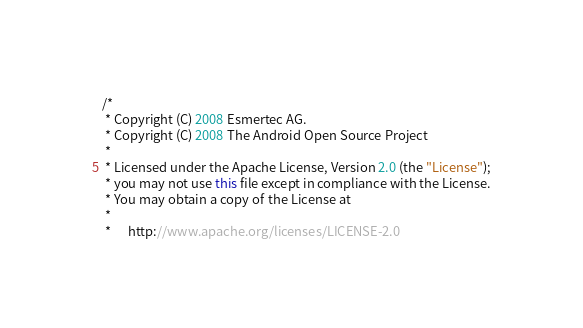Convert code to text. <code><loc_0><loc_0><loc_500><loc_500><_Java_>/*
 * Copyright (C) 2008 Esmertec AG.
 * Copyright (C) 2008 The Android Open Source Project
 *
 * Licensed under the Apache License, Version 2.0 (the "License");
 * you may not use this file except in compliance with the License.
 * You may obtain a copy of the License at
 *
 *      http://www.apache.org/licenses/LICENSE-2.0</code> 